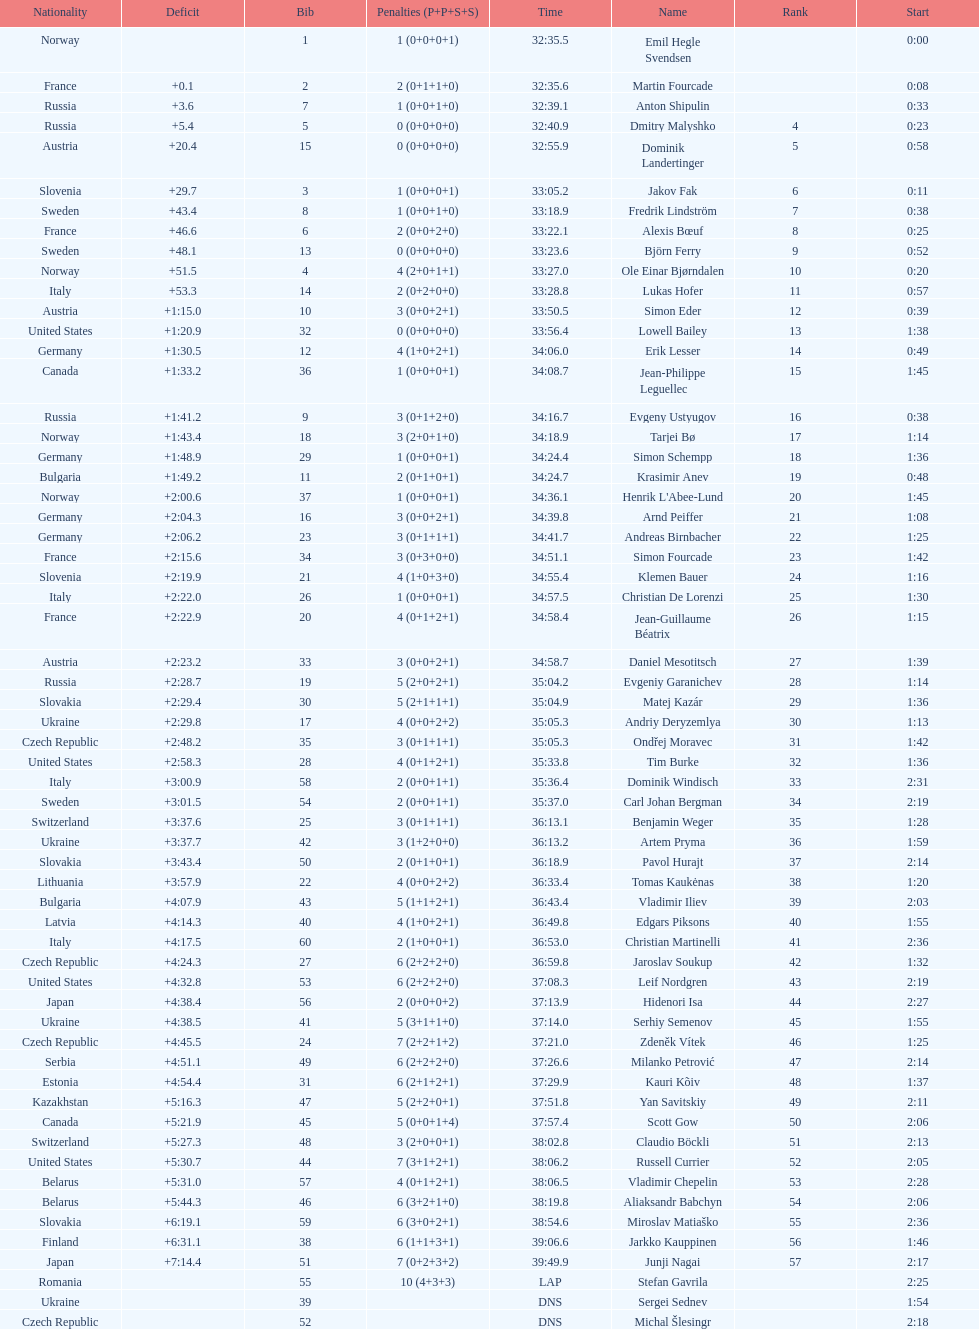What were the total number of "ties" (people who finished with the exact same time?) 2. 